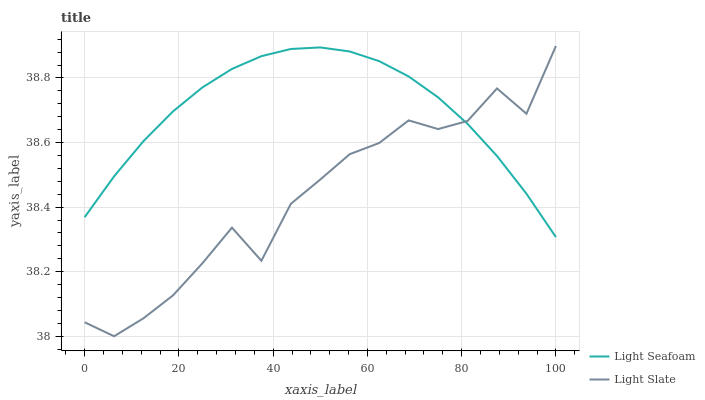Does Light Slate have the minimum area under the curve?
Answer yes or no. Yes. Does Light Seafoam have the maximum area under the curve?
Answer yes or no. Yes. Does Light Seafoam have the minimum area under the curve?
Answer yes or no. No. Is Light Seafoam the smoothest?
Answer yes or no. Yes. Is Light Slate the roughest?
Answer yes or no. Yes. Is Light Seafoam the roughest?
Answer yes or no. No. Does Light Slate have the lowest value?
Answer yes or no. Yes. Does Light Seafoam have the lowest value?
Answer yes or no. No. Does Light Slate have the highest value?
Answer yes or no. Yes. Does Light Seafoam have the highest value?
Answer yes or no. No. Does Light Seafoam intersect Light Slate?
Answer yes or no. Yes. Is Light Seafoam less than Light Slate?
Answer yes or no. No. Is Light Seafoam greater than Light Slate?
Answer yes or no. No. 